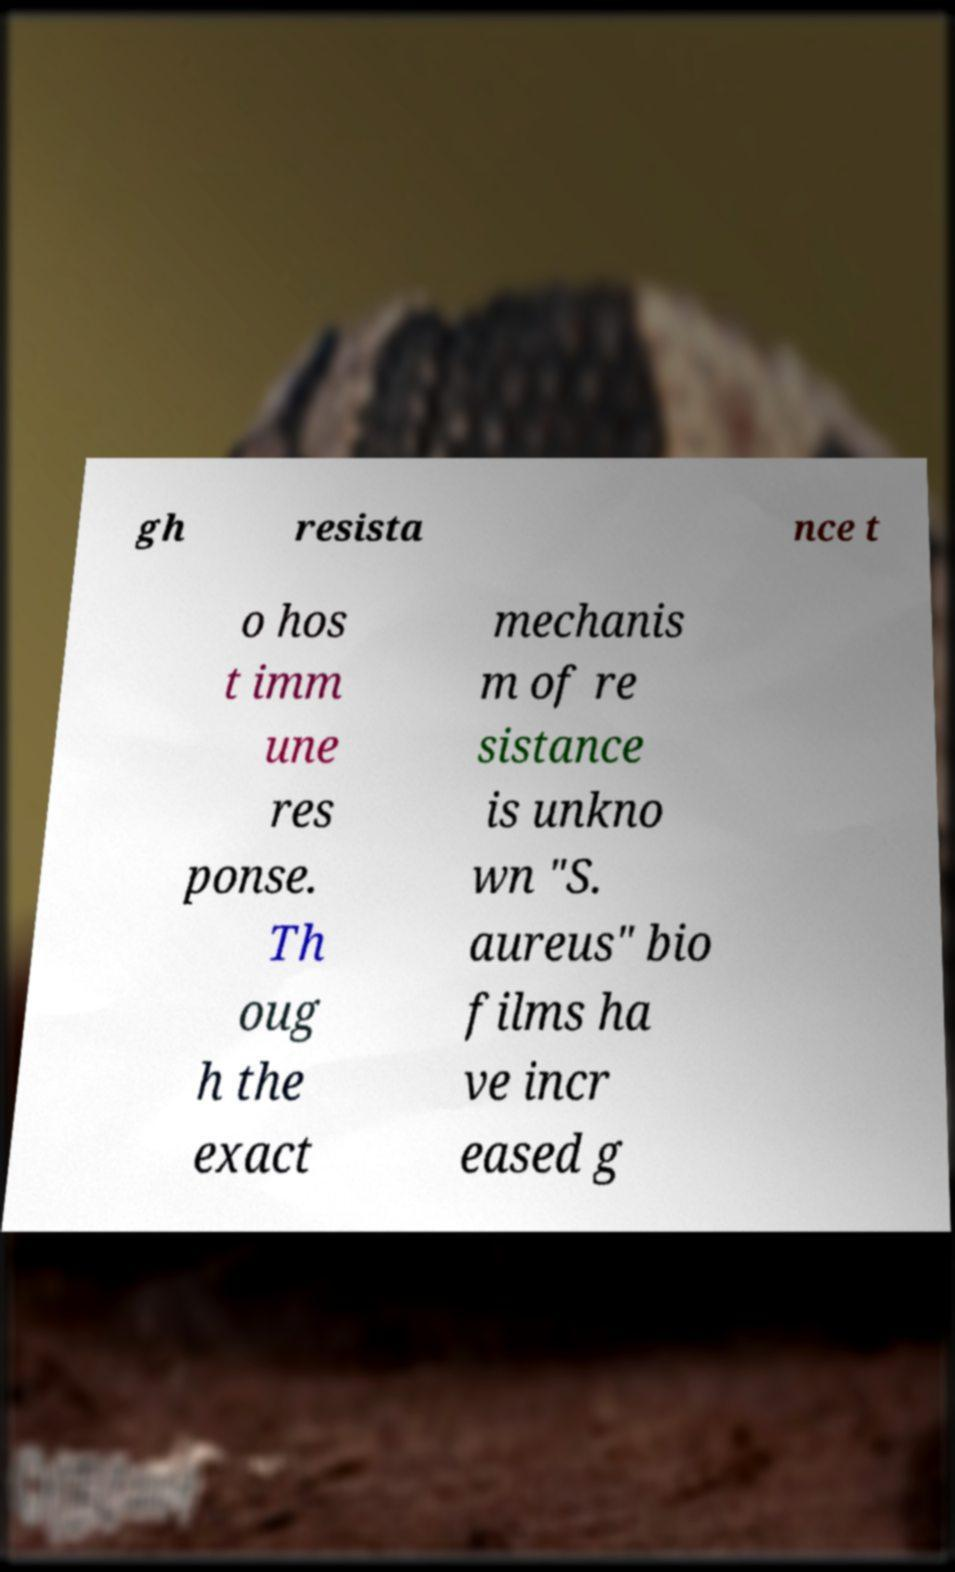For documentation purposes, I need the text within this image transcribed. Could you provide that? gh resista nce t o hos t imm une res ponse. Th oug h the exact mechanis m of re sistance is unkno wn "S. aureus" bio films ha ve incr eased g 